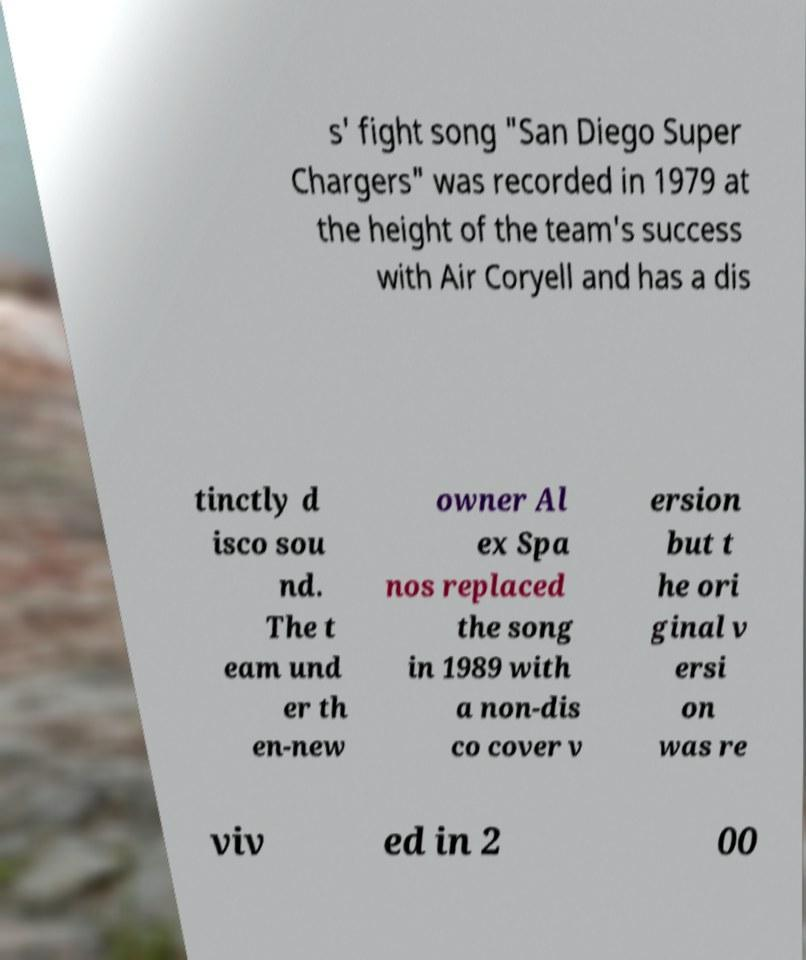There's text embedded in this image that I need extracted. Can you transcribe it verbatim? s' fight song "San Diego Super Chargers" was recorded in 1979 at the height of the team's success with Air Coryell and has a dis tinctly d isco sou nd. The t eam und er th en-new owner Al ex Spa nos replaced the song in 1989 with a non-dis co cover v ersion but t he ori ginal v ersi on was re viv ed in 2 00 